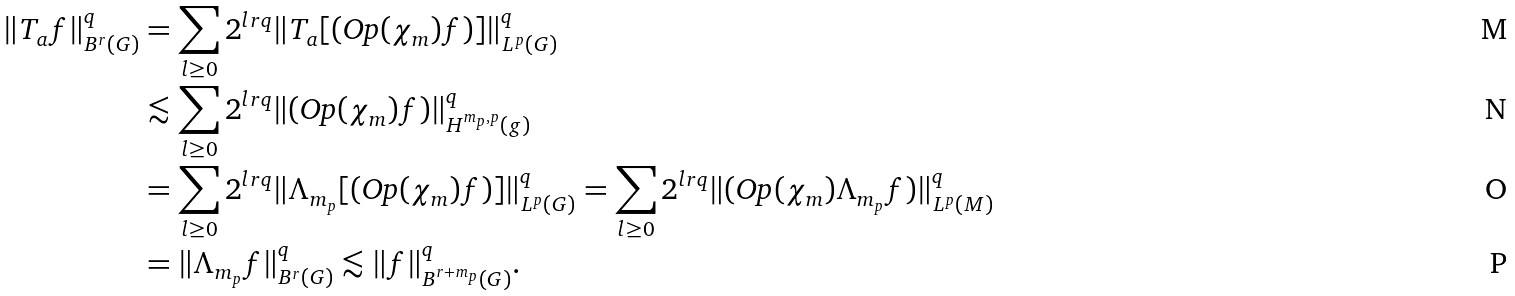Convert formula to latex. <formula><loc_0><loc_0><loc_500><loc_500>\| T _ { a } f \| ^ { q } _ { B ^ { r } ( G ) } & = \sum _ { l \geq 0 } 2 ^ { l r q } \| T _ { a } [ ( \text {Op} ( \chi _ { m } ) f ) ] \| ^ { q } _ { L ^ { p } ( G ) } \\ & \lesssim \sum _ { l \geq 0 } 2 ^ { l r q } \| ( \text {Op} ( \chi _ { m } ) f ) \| ^ { q } _ { H ^ { m _ { p } , p } ( g ) } \\ & = \sum _ { l \geq 0 } 2 ^ { l r q } \| \Lambda _ { m _ { p } } [ ( \text {Op} ( \chi _ { m } ) f ) ] \| ^ { q } _ { L ^ { p } ( G ) } = \sum _ { l \geq 0 } 2 ^ { l r q } \| ( \text {Op} ( \chi _ { m } ) \Lambda _ { m _ { p } } f ) \| ^ { q } _ { L ^ { p } ( M ) } \\ & = \| \Lambda _ { m _ { p } } f \| ^ { q } _ { B ^ { r } ( G ) } \lesssim \| f \| ^ { q } _ { B ^ { r + m _ { p } } ( G ) } .</formula> 